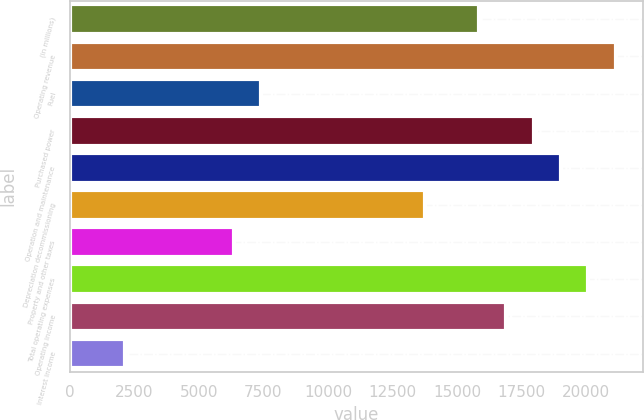Convert chart to OTSL. <chart><loc_0><loc_0><loc_500><loc_500><bar_chart><fcel>(in millions)<fcel>Operating revenue<fcel>Fuel<fcel>Purchased power<fcel>Operation and maintenance<fcel>Depreciation decommissioning<fcel>Property and other taxes<fcel>Total operating expenses<fcel>Operating income<fcel>Interest income<nl><fcel>15864<fcel>21151<fcel>7404.8<fcel>17978.8<fcel>19036.2<fcel>13749.2<fcel>6347.4<fcel>20093.6<fcel>16921.4<fcel>2117.8<nl></chart> 